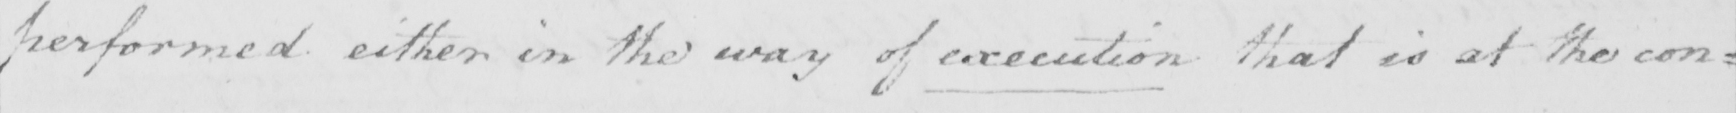What text is written in this handwritten line? performed either in the way of execution that is at the con= 